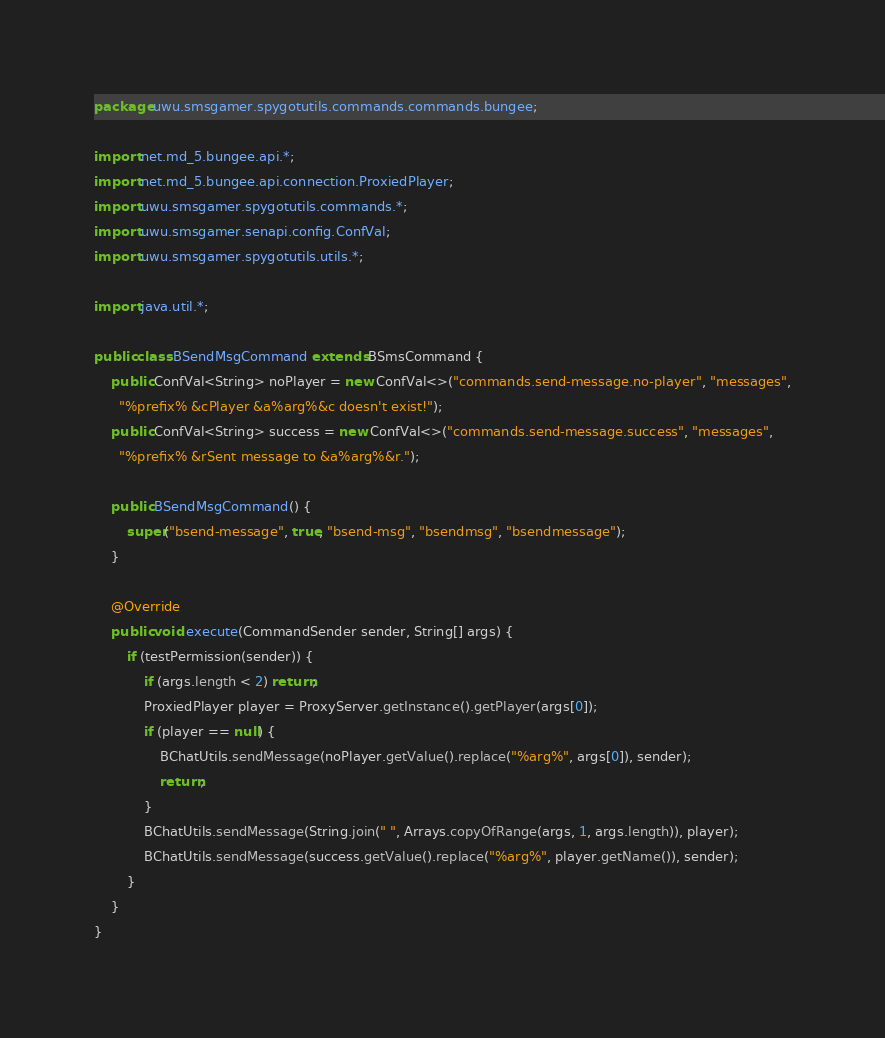<code> <loc_0><loc_0><loc_500><loc_500><_Java_>package uwu.smsgamer.spygotutils.commands.commands.bungee;

import net.md_5.bungee.api.*;
import net.md_5.bungee.api.connection.ProxiedPlayer;
import uwu.smsgamer.spygotutils.commands.*;
import uwu.smsgamer.senapi.config.ConfVal;
import uwu.smsgamer.spygotutils.utils.*;

import java.util.*;

public class BSendMsgCommand extends BSmsCommand {
    public ConfVal<String> noPlayer = new ConfVal<>("commands.send-message.no-player", "messages",
      "%prefix% &cPlayer &a%arg%&c doesn't exist!");
    public ConfVal<String> success = new ConfVal<>("commands.send-message.success", "messages",
      "%prefix% &rSent message to &a%arg%&r.");

    public BSendMsgCommand() {
        super("bsend-message", true, "bsend-msg", "bsendmsg", "bsendmessage");
    }

    @Override
    public void execute(CommandSender sender, String[] args) {
        if (testPermission(sender)) {
            if (args.length < 2) return;
            ProxiedPlayer player = ProxyServer.getInstance().getPlayer(args[0]);
            if (player == null) {
                BChatUtils.sendMessage(noPlayer.getValue().replace("%arg%", args[0]), sender);
                return;
            }
            BChatUtils.sendMessage(String.join(" ", Arrays.copyOfRange(args, 1, args.length)), player);
            BChatUtils.sendMessage(success.getValue().replace("%arg%", player.getName()), sender);
        }
    }
}
</code> 